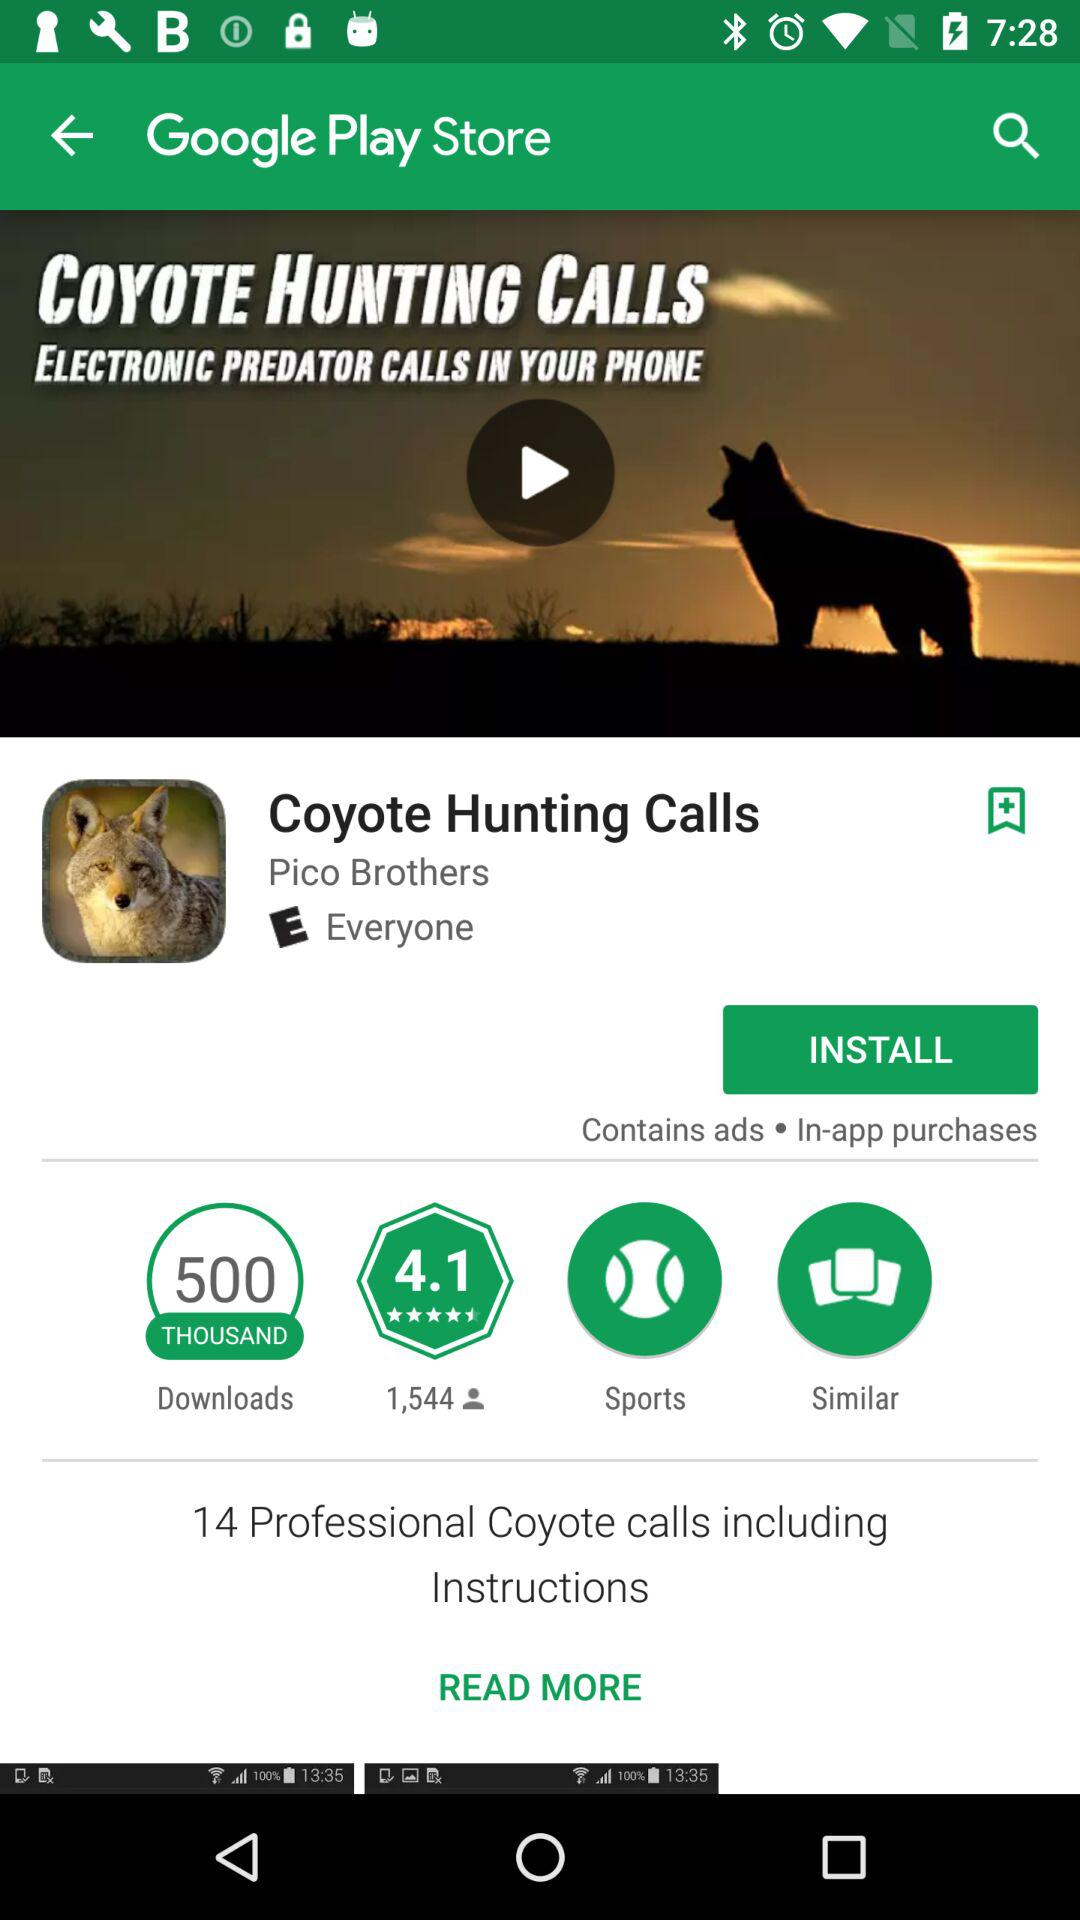Who developed the "Coyote Hunting Calls"? The "Coyote Hunting Calls" application was developed by "Pico Brothers". 